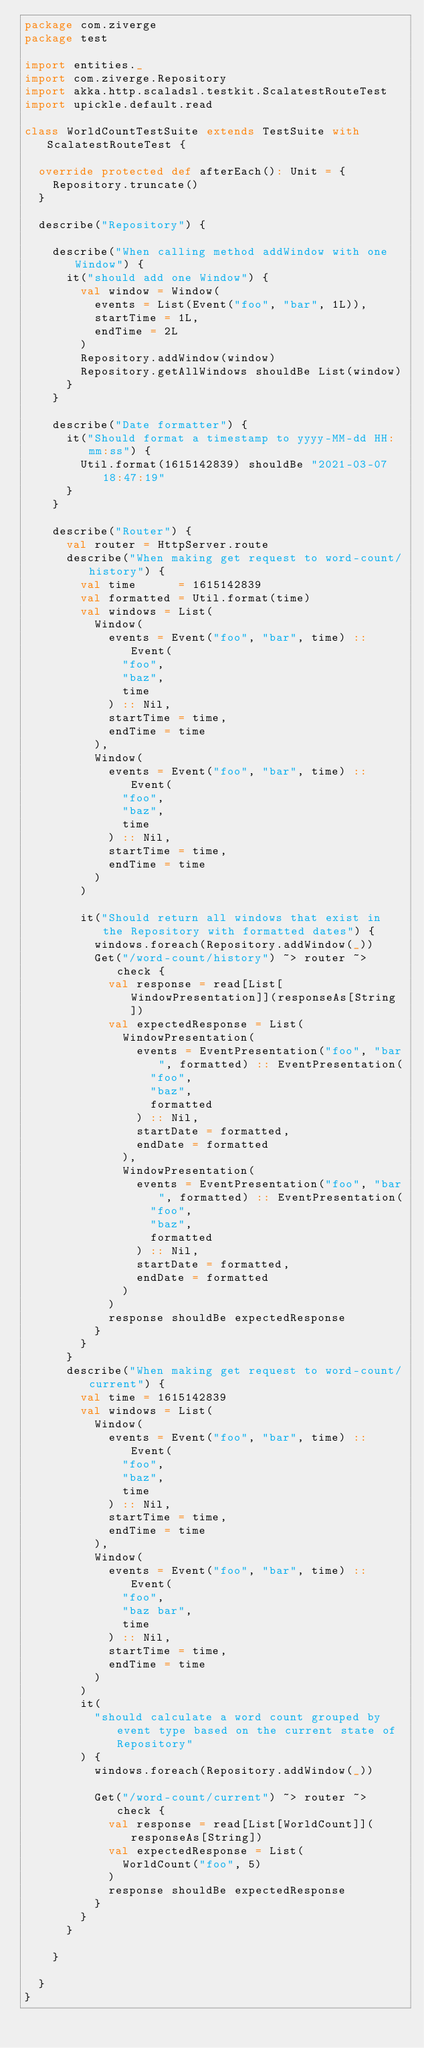<code> <loc_0><loc_0><loc_500><loc_500><_Scala_>package com.ziverge
package test

import entities._
import com.ziverge.Repository
import akka.http.scaladsl.testkit.ScalatestRouteTest
import upickle.default.read

class WorldCountTestSuite extends TestSuite with ScalatestRouteTest {

  override protected def afterEach(): Unit = {
    Repository.truncate()
  }

  describe("Repository") {

    describe("When calling method addWindow with one Window") {
      it("should add one Window") {
        val window = Window(
          events = List(Event("foo", "bar", 1L)),
          startTime = 1L,
          endTime = 2L
        )
        Repository.addWindow(window)
        Repository.getAllWindows shouldBe List(window)
      }
    }

    describe("Date formatter") {
      it("Should format a timestamp to yyyy-MM-dd HH:mm:ss") {
        Util.format(1615142839) shouldBe "2021-03-07 18:47:19"
      }
    }

    describe("Router") {
      val router = HttpServer.route
      describe("When making get request to word-count/history") {
        val time      = 1615142839
        val formatted = Util.format(time)
        val windows = List(
          Window(
            events = Event("foo", "bar", time) :: Event(
              "foo",
              "baz",
              time
            ) :: Nil,
            startTime = time,
            endTime = time
          ),
          Window(
            events = Event("foo", "bar", time) :: Event(
              "foo",
              "baz",
              time
            ) :: Nil,
            startTime = time,
            endTime = time
          )
        )

        it("Should return all windows that exist in the Repository with formatted dates") {
          windows.foreach(Repository.addWindow(_))
          Get("/word-count/history") ~> router ~> check {
            val response = read[List[WindowPresentation]](responseAs[String])
            val expectedResponse = List(
              WindowPresentation(
                events = EventPresentation("foo", "bar", formatted) :: EventPresentation(
                  "foo",
                  "baz",
                  formatted
                ) :: Nil,
                startDate = formatted,
                endDate = formatted
              ),
              WindowPresentation(
                events = EventPresentation("foo", "bar", formatted) :: EventPresentation(
                  "foo",
                  "baz",
                  formatted
                ) :: Nil,
                startDate = formatted,
                endDate = formatted
              )
            )
            response shouldBe expectedResponse
          }
        }
      }
      describe("When making get request to word-count/current") {
        val time = 1615142839
        val windows = List(
          Window(
            events = Event("foo", "bar", time) :: Event(
              "foo",
              "baz",
              time
            ) :: Nil,
            startTime = time,
            endTime = time
          ),
          Window(
            events = Event("foo", "bar", time) :: Event(
              "foo",
              "baz bar",
              time
            ) :: Nil,
            startTime = time,
            endTime = time
          )
        )
        it(
          "should calculate a word count grouped by event type based on the current state of Repository"
        ) {
          windows.foreach(Repository.addWindow(_))

          Get("/word-count/current") ~> router ~> check {
            val response = read[List[WorldCount]](responseAs[String])
            val expectedResponse = List(
              WorldCount("foo", 5)
            )
            response shouldBe expectedResponse
          }
        }
      }

    }

  }
}
</code> 